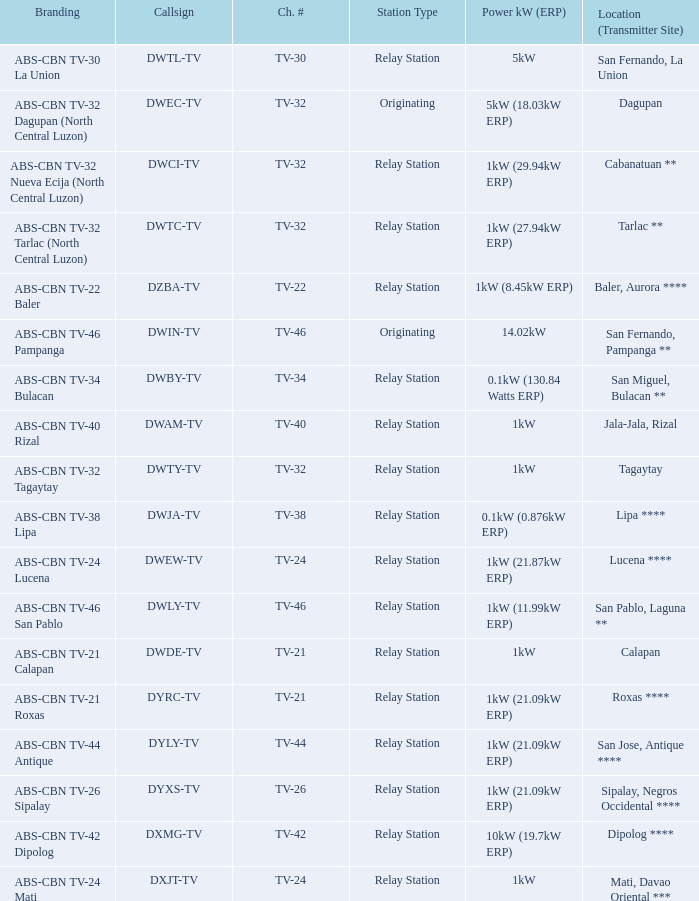The location (transmitter site) San Fernando, Pampanga ** has what Power kW (ERP)? 14.02kW. 